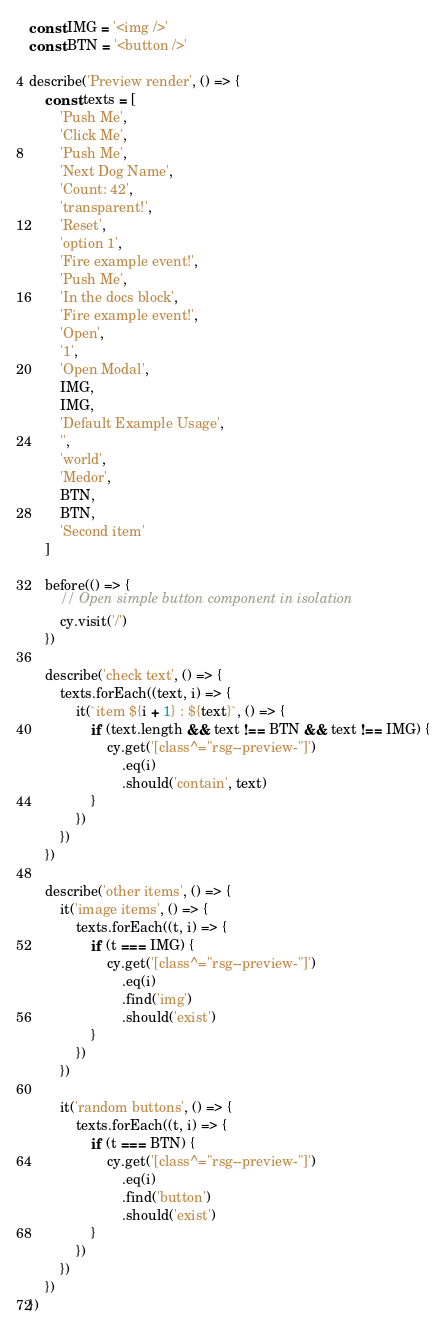Convert code to text. <code><loc_0><loc_0><loc_500><loc_500><_JavaScript_>const IMG = '<img />'
const BTN = '<button />'

describe('Preview render', () => {
	const texts = [
		'Push Me',
		'Click Me',
		'Push Me',
		'Next Dog Name',
		'Count: 42',
		'transparent!',
		'Reset',
		'option 1',
		'Fire example event!',
		'Push Me',
		'In the docs block',
		'Fire example event!',
		'Open',
		'1',
		'Open Modal',
		IMG,
		IMG,
		'Default Example Usage',
		'',
		'world',
		'Medor',
		BTN,
		BTN,
		'Second item'
	]

	before(() => {
		// Open simple button component in isolation
		cy.visit('/')
	})

	describe('check text', () => {
		texts.forEach((text, i) => {
			it(`item ${i + 1} : ${text}`, () => {
				if (text.length && text !== BTN && text !== IMG) {
					cy.get('[class^="rsg--preview-"]')
						.eq(i)
						.should('contain', text)
				}
			})
		})
	})

	describe('other items', () => {
		it('image items', () => {
			texts.forEach((t, i) => {
				if (t === IMG) {
					cy.get('[class^="rsg--preview-"]')
						.eq(i)
						.find('img')
						.should('exist')
				}
			})
		})

		it('random buttons', () => {
			texts.forEach((t, i) => {
				if (t === BTN) {
					cy.get('[class^="rsg--preview-"]')
						.eq(i)
						.find('button')
						.should('exist')
				}
			})
		})
	})
})
</code> 